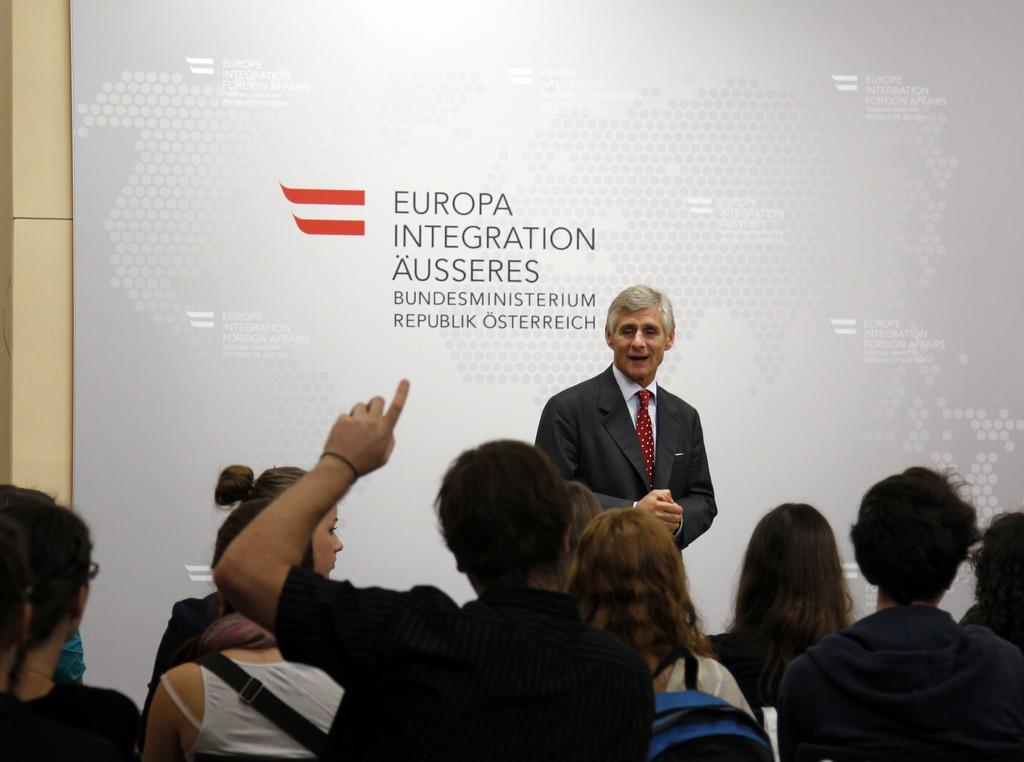How would you summarize this image in a sentence or two? In this picture there is a man who is wearing suit. He is standing near to the board. At the bottom we can see the group of persons were sitting on the chair. 